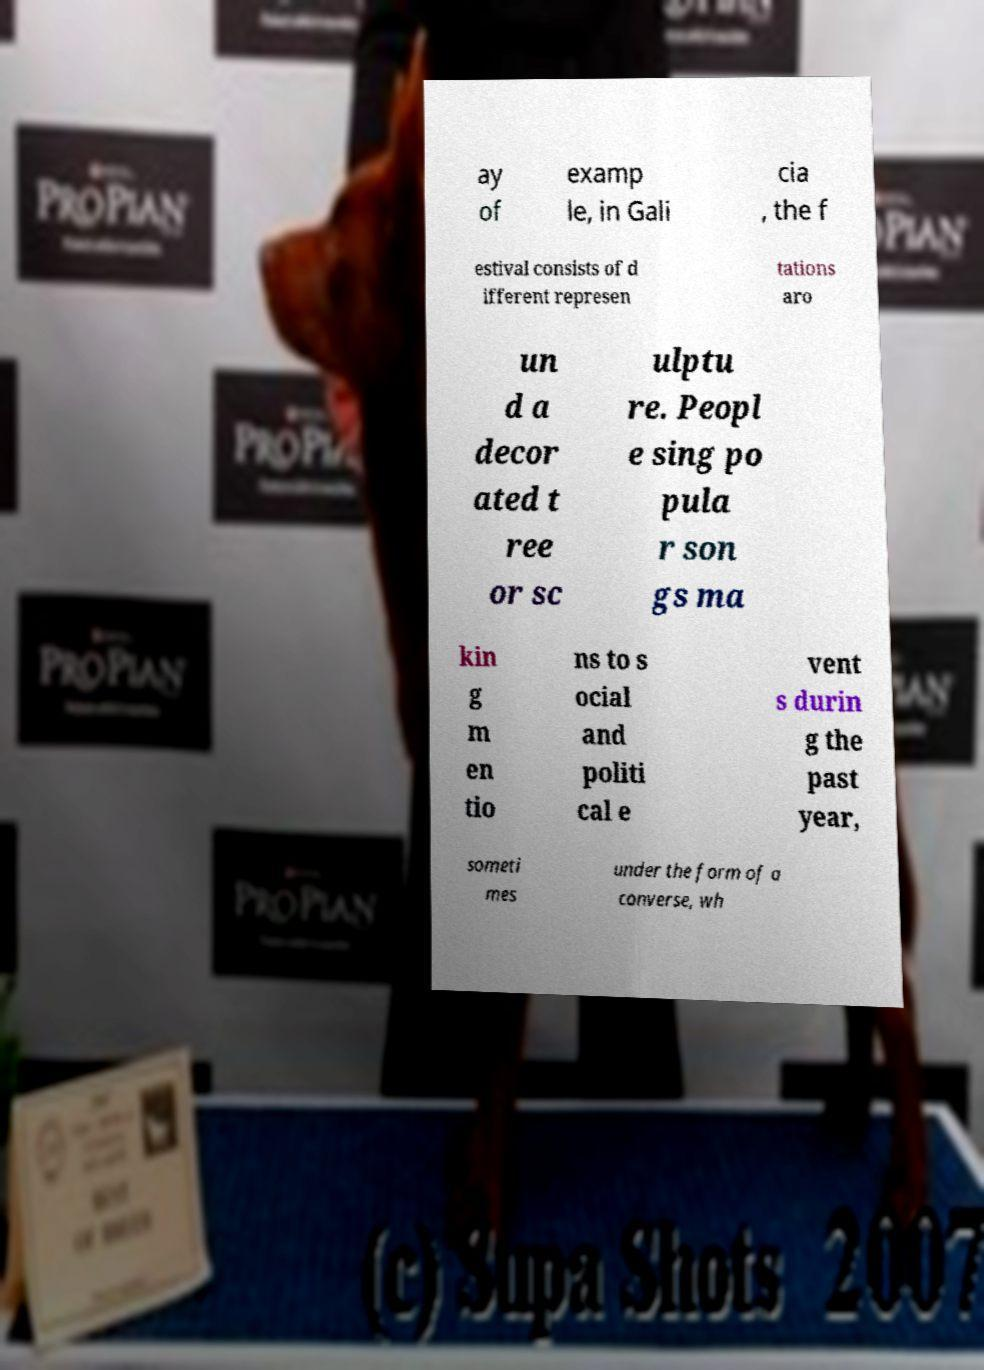I need the written content from this picture converted into text. Can you do that? ay of examp le, in Gali cia , the f estival consists of d ifferent represen tations aro un d a decor ated t ree or sc ulptu re. Peopl e sing po pula r son gs ma kin g m en tio ns to s ocial and politi cal e vent s durin g the past year, someti mes under the form of a converse, wh 